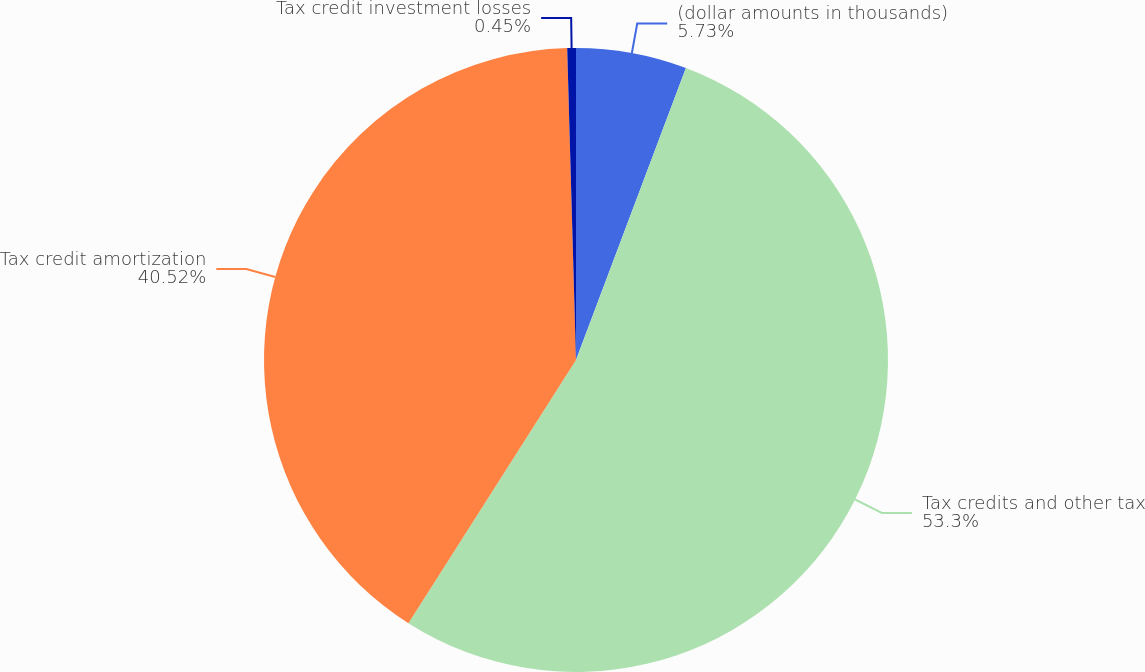Convert chart. <chart><loc_0><loc_0><loc_500><loc_500><pie_chart><fcel>(dollar amounts in thousands)<fcel>Tax credits and other tax<fcel>Tax credit amortization<fcel>Tax credit investment losses<nl><fcel>5.73%<fcel>53.29%<fcel>40.52%<fcel>0.45%<nl></chart> 